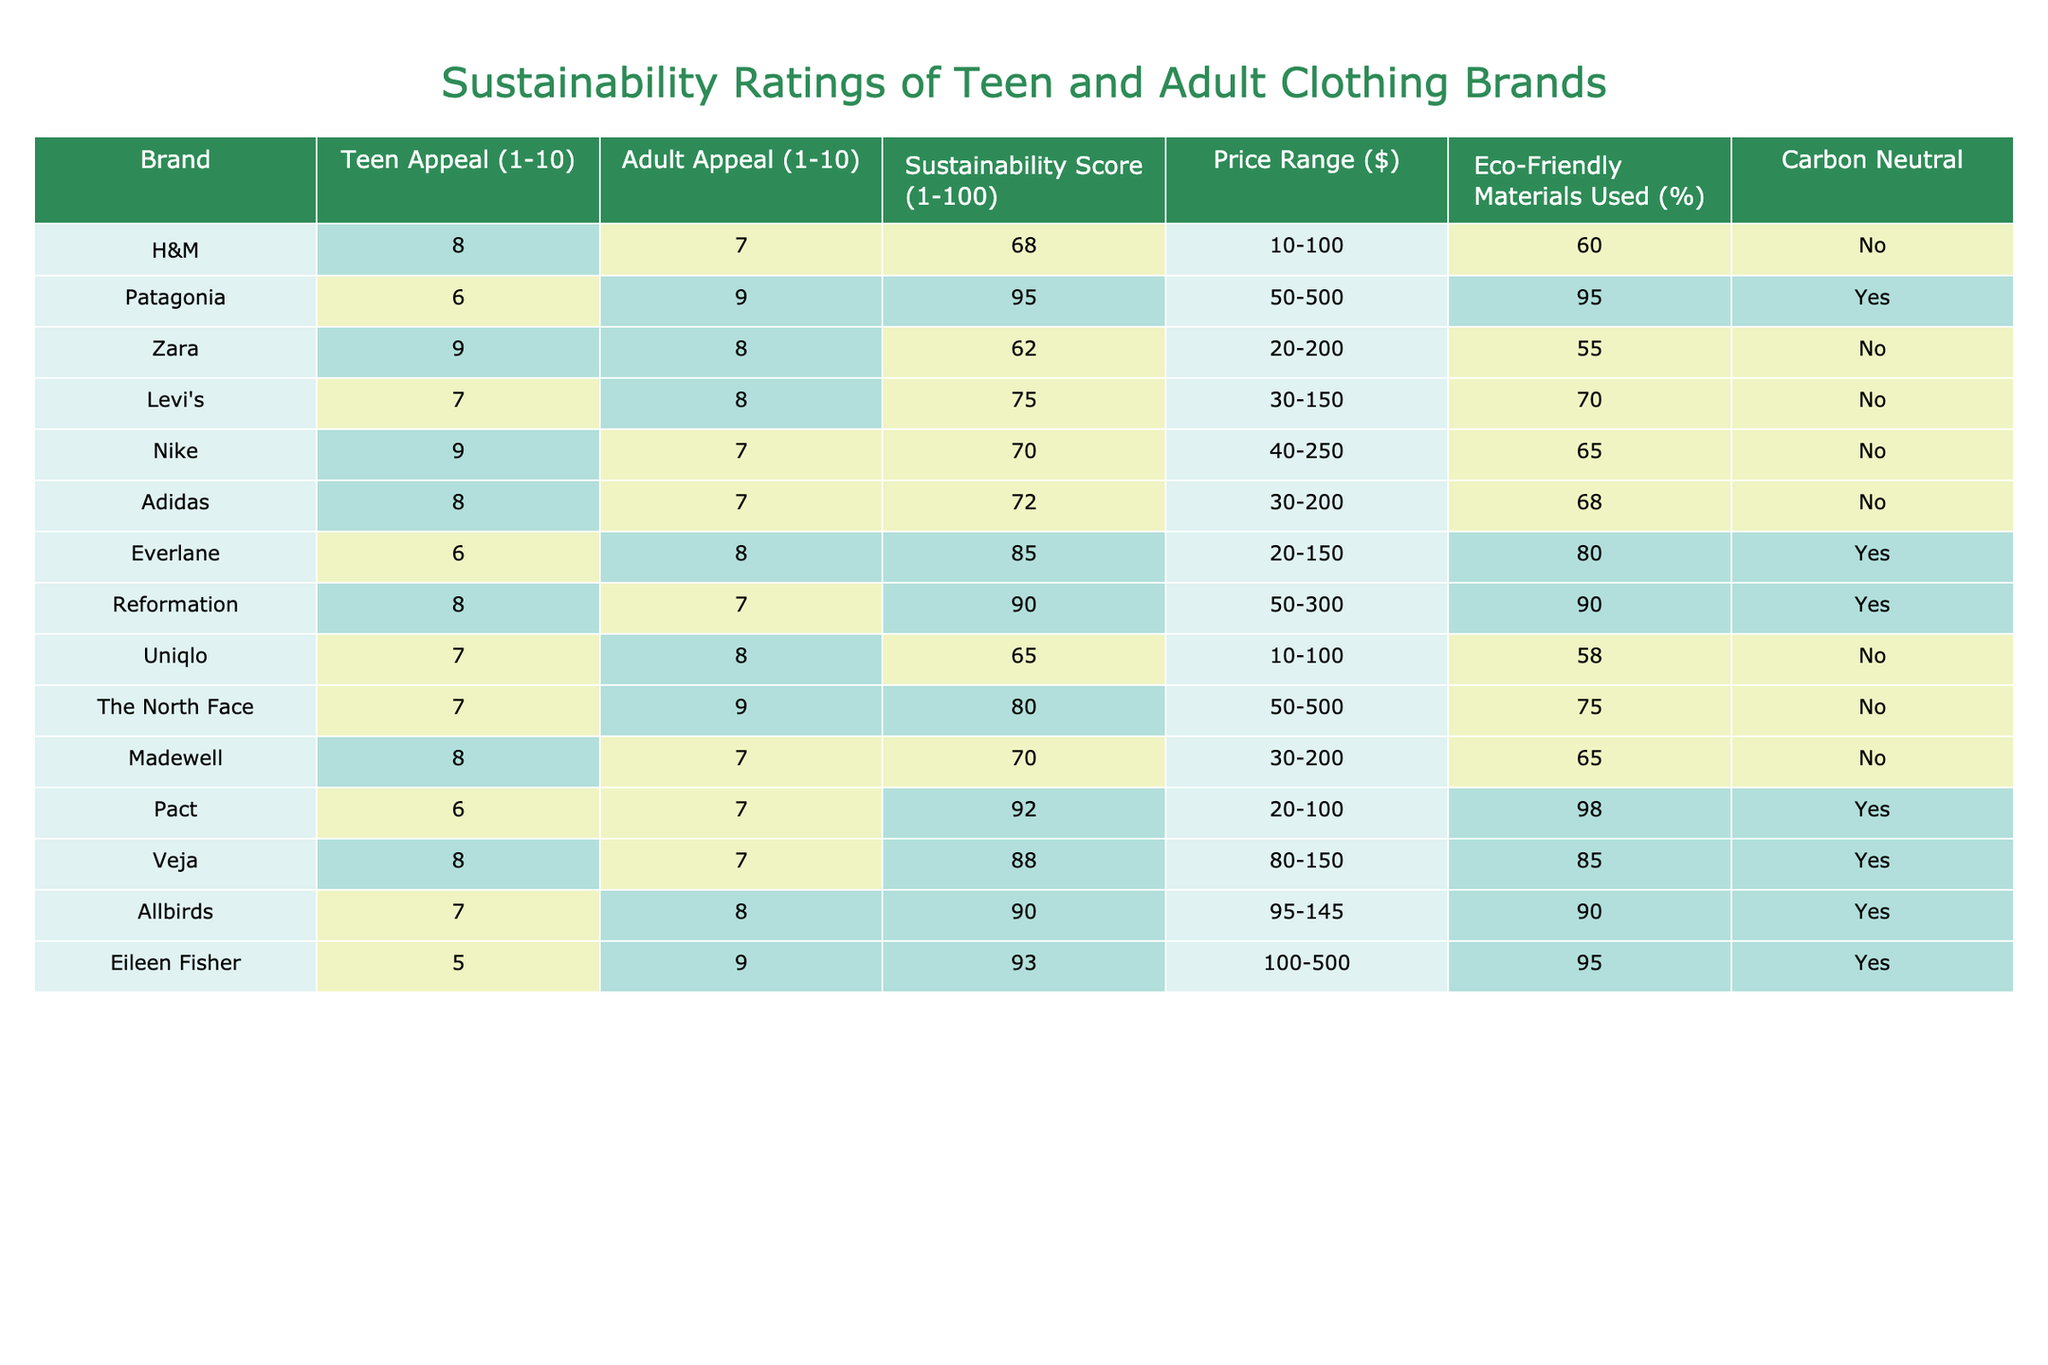What brand has the highest sustainability score? The sustainability scores are H&M (68), Patagonia (95), Zara (62), Levi's (75), Nike (70), Adidas (72), Everlane (85), Reformation (90), Uniqlo (65), The North Face (80), Madewell (70), Pact (92), Veja (88), Allbirds (90), and Eileen Fisher (93). The highest score is Patagonia at 95.
Answer: Patagonia Which brand is carbon neutral and also uses eco-friendly materials at least 80% of the time? The brands that are carbon neutral are Patagonia, Everlane, Pact, Veja, Allbirds, and Eileen Fisher. Among this list, the brands using eco-friendly materials over 80% are Patagonia (95%), Everlane (80%), Pact (98%), Veja (85%), and Allbirds (90%). Thus, Pact is the only one that exceeds this threshold and is carbon neutral.
Answer: Pact What is the average price range of brands appealing to teens with scores 8 or higher in sustainability? The brands appealing to teens with scores 8 or higher in sustainability are H&M ($10-100), Zara ($20-200), Nike ($40-250), Adidas ($30-200), Reformation ($50-300), Veja ($80-150), and Allbirds ($95-145). The average price can be found by converting ranges into midpoints and averaging them. Average price points: H&M (55), Zara (110), Nike (145), Adidas (115), Reformation (175), Veja (115), Allbirds (120.
Answer: 115 What percentage of brands appeal more to adults than teens, based on appeal scores? By looking at the appeal scores, we can compare the scores for each brand. The brands that appeal more to adults than teens are Patagonia (6 vs 9), Levi's (7 vs 8), The North Face (7 vs 9), and Eileen Fisher (5 vs 9). Out of the 15 brands, 4 fit this criterion. The percentage is calculated by dividing 4 by 15, giving us approximately 26.67%.
Answer: 26.67% Which brand has a sustainability score of over 90 and is appealing to teens? The brands with a sustainability score above 90 are Patagonia (95), Everlane (85), Reformation (90), Pact (92), Veja (88), Allbirds (90), and Eileen Fisher (93). Among these, only Pact has a teen appeal score lower than 8, while the rest have scores below. Therefore, only Pact stands out with over 90 sustainability score and appeal for teens.
Answer: Pact How many brands have a sustainability score below 70 and appeal to teens with a score of 8 or higher? Checking the sustainability scores: H&M (68), Zara (62), and Uniqlo (65) have scores below 70. Among these, only H&M (8) and Zara (9) have an appeal score of 8 or higher. So the count is 2 brands fitting this description.
Answer: 2 